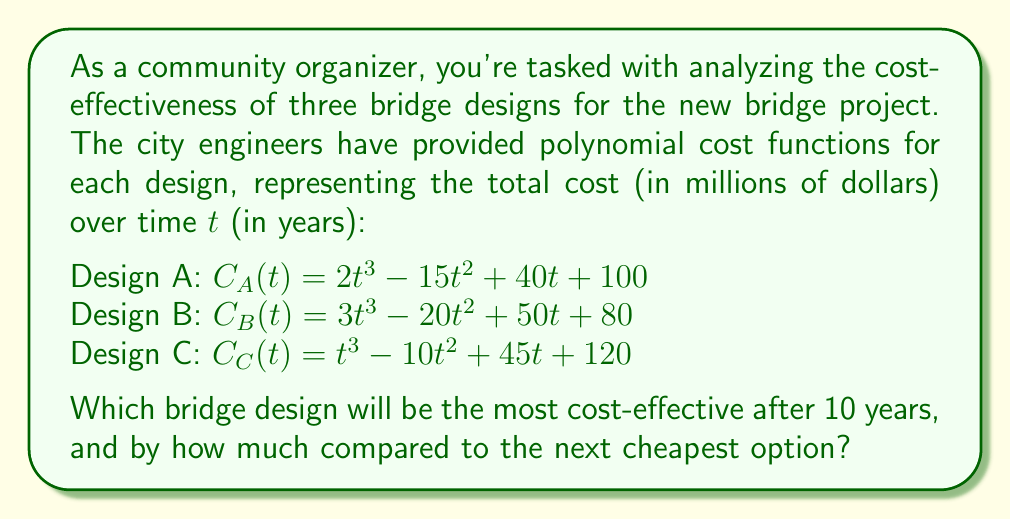Could you help me with this problem? To determine the most cost-effective bridge design after 10 years, we need to evaluate each cost function at t = 10 and compare the results.

1. For Design A:
   $C_A(10) = 2(10)^3 - 15(10)^2 + 40(10) + 100$
   $= 2000 - 1500 + 400 + 100 = 1000$ million dollars

2. For Design B:
   $C_B(10) = 3(10)^3 - 20(10)^2 + 50(10) + 80$
   $= 3000 - 2000 + 500 + 80 = 1580$ million dollars

3. For Design C:
   $C_C(10) = (10)^3 - 10(10)^2 + 45(10) + 120$
   $= 1000 - 1000 + 450 + 120 = 570$ million dollars

Comparing the results:
Design C is the cheapest at $570 million
Design A is the second cheapest at $1000 million
Design B is the most expensive at $1580 million

To find how much cheaper Design C is compared to the next cheapest option (Design A):
$1000 - 570 = 430$ million dollars
Answer: Design C will be the most cost-effective after 10 years, and it will be $430 million cheaper than the next cheapest option (Design A). 